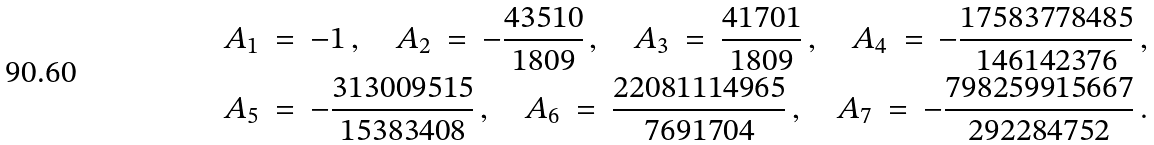<formula> <loc_0><loc_0><loc_500><loc_500>A _ { 1 } \ = \ - 1 \, , \quad A _ { 2 } \ = \ - \frac { 4 3 5 1 0 } { 1 8 0 9 } \, , \quad A _ { 3 } \ = \ \frac { 4 1 7 0 1 } { 1 8 0 9 } \, , \quad A _ { 4 } \ = \ - \frac { 1 7 5 8 3 7 7 8 4 8 5 } { 1 4 6 1 4 2 3 7 6 } \, , \\ A _ { 5 } \ = \ - \frac { 3 1 3 0 0 9 5 1 5 } { 1 5 3 8 3 4 0 8 } \, , \quad A _ { 6 } \ = \ \frac { 2 2 0 8 1 1 1 4 9 6 5 } { 7 6 9 1 7 0 4 } \, , \quad A _ { 7 } \ = \ - \frac { 7 9 8 2 5 9 9 1 5 6 6 7 } { 2 9 2 2 8 4 7 5 2 } \, .</formula> 